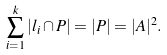Convert formula to latex. <formula><loc_0><loc_0><loc_500><loc_500>\sum _ { i = 1 } ^ { k } | l _ { i } \cap { P } | = | P | = | A | ^ { 2 } .</formula> 